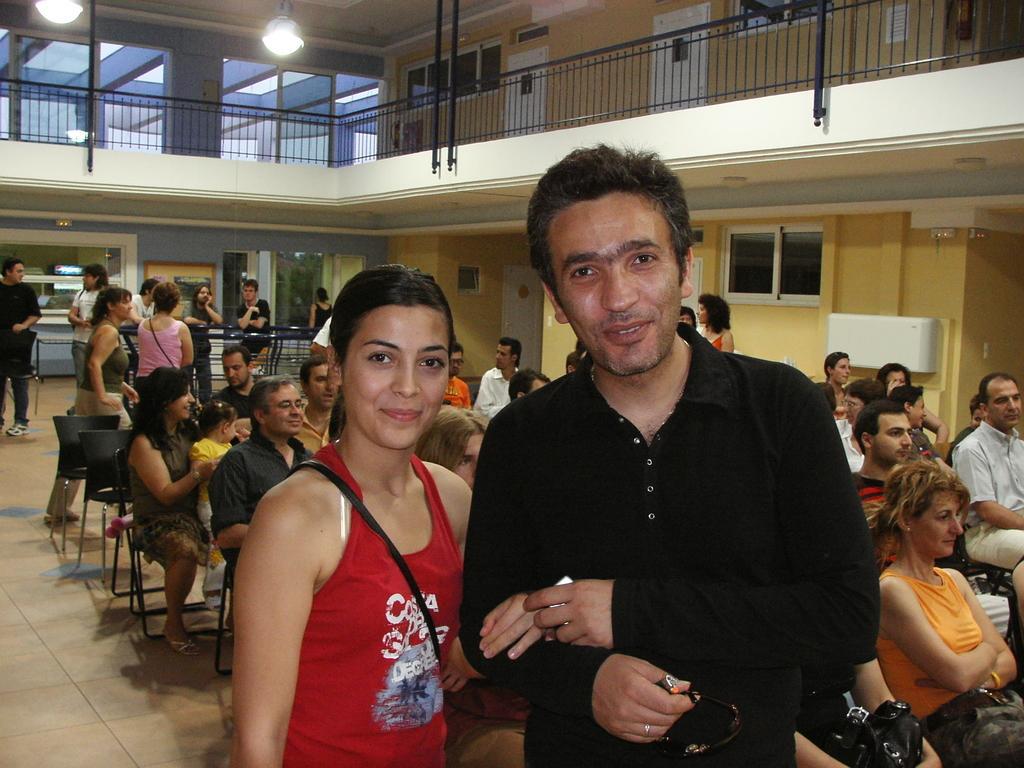Please provide a concise description of this image. In the image we can see there are people standing and there are other people sitting on the chair. There are windows and doors on the wall. There are lights on the top and there are iron railings. 